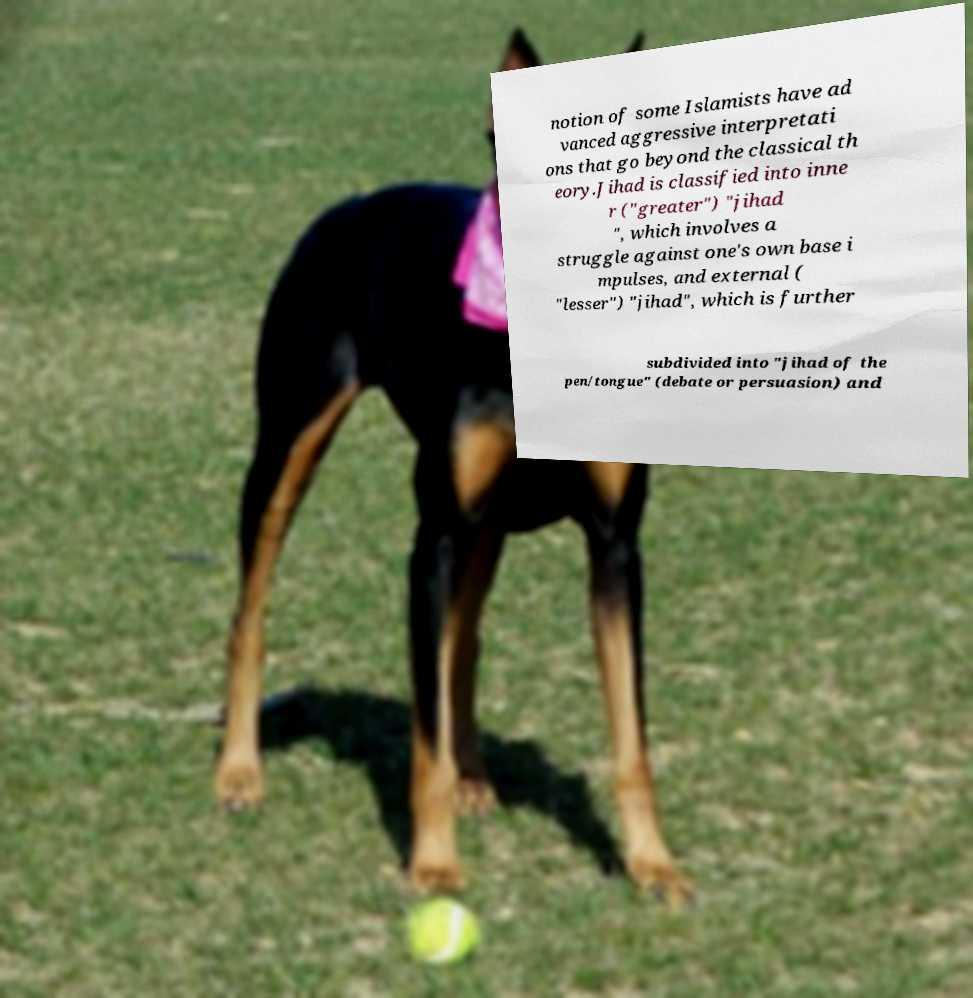Could you assist in decoding the text presented in this image and type it out clearly? notion of some Islamists have ad vanced aggressive interpretati ons that go beyond the classical th eory.Jihad is classified into inne r ("greater") "jihad ", which involves a struggle against one's own base i mpulses, and external ( "lesser") "jihad", which is further subdivided into "jihad of the pen/tongue" (debate or persuasion) and 